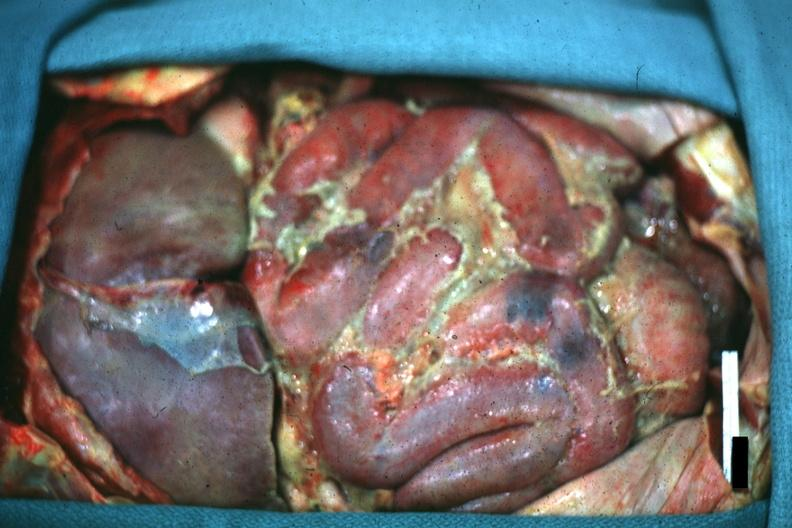s acute peritonitis present?
Answer the question using a single word or phrase. Yes 